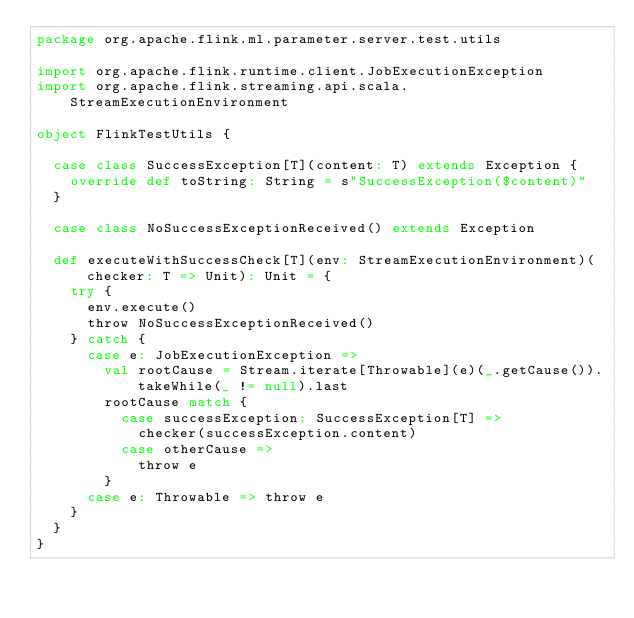Convert code to text. <code><loc_0><loc_0><loc_500><loc_500><_Scala_>package org.apache.flink.ml.parameter.server.test.utils

import org.apache.flink.runtime.client.JobExecutionException
import org.apache.flink.streaming.api.scala.StreamExecutionEnvironment

object FlinkTestUtils {

  case class SuccessException[T](content: T) extends Exception {
    override def toString: String = s"SuccessException($content)"
  }

  case class NoSuccessExceptionReceived() extends Exception

  def executeWithSuccessCheck[T](env: StreamExecutionEnvironment)(checker: T => Unit): Unit = {
    try {
      env.execute()
      throw NoSuccessExceptionReceived()
    } catch {
      case e: JobExecutionException =>
        val rootCause = Stream.iterate[Throwable](e)(_.getCause()).takeWhile(_ != null).last
        rootCause match {
          case successException: SuccessException[T] =>
            checker(successException.content)
          case otherCause =>
            throw e
        }
      case e: Throwable => throw e
    }
  }
}
</code> 